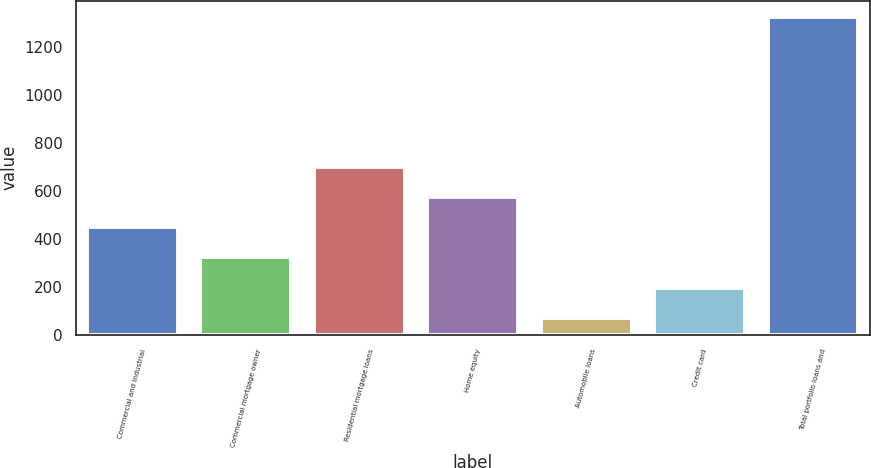<chart> <loc_0><loc_0><loc_500><loc_500><bar_chart><fcel>Commercial and industrial<fcel>Commercial mortgage owner<fcel>Residential mortgage loans<fcel>Home equity<fcel>Automobile loans<fcel>Credit card<fcel>Total portfolio loans and<nl><fcel>447.9<fcel>322.6<fcel>698.5<fcel>573.2<fcel>72<fcel>197.3<fcel>1325<nl></chart> 